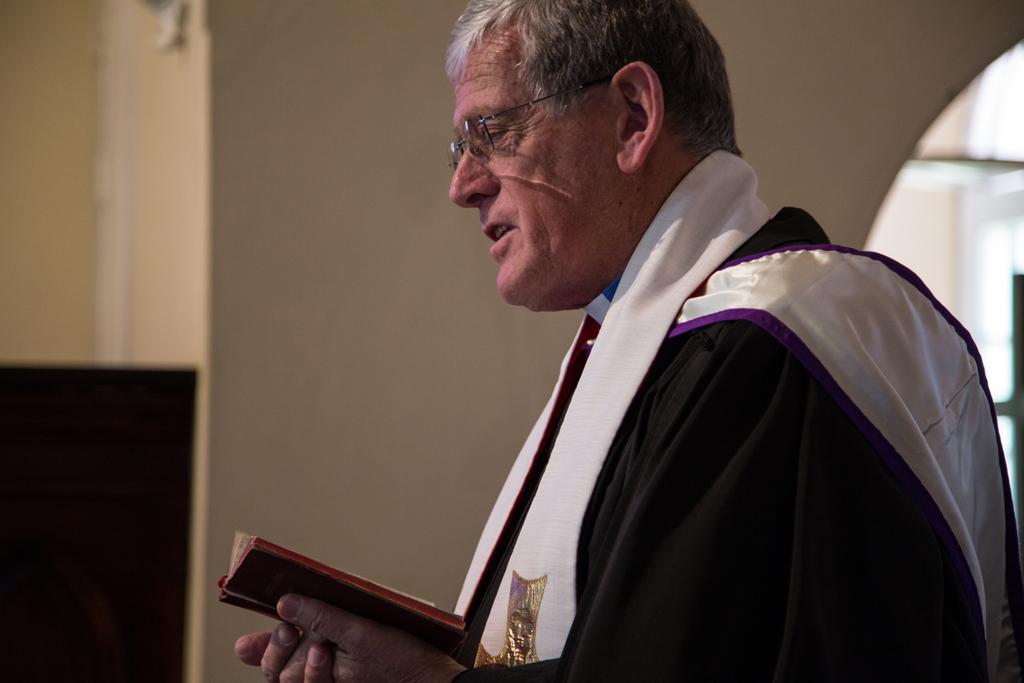In one or two sentences, can you explain what this image depicts? In this image we can see a man holding a book in the hands. In the background there are walls. 